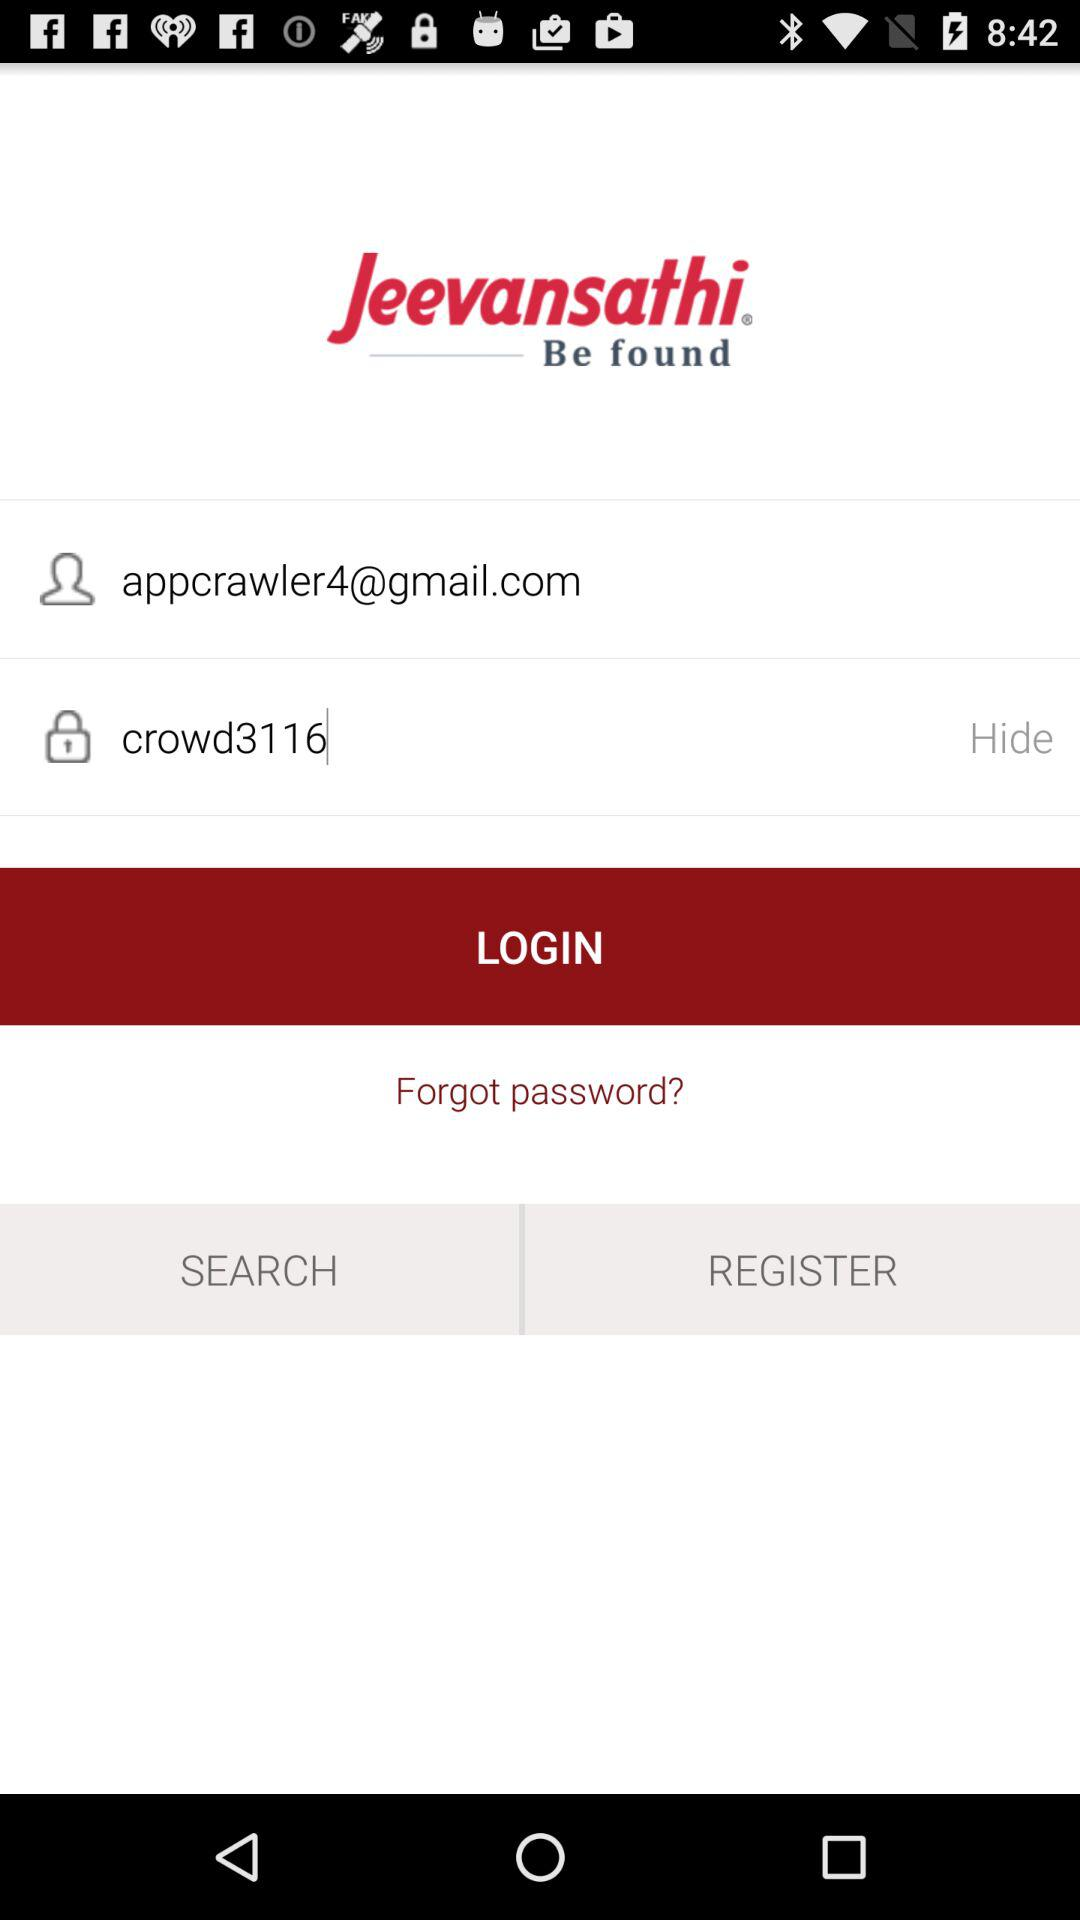What is the password? The password is crowd3116. 